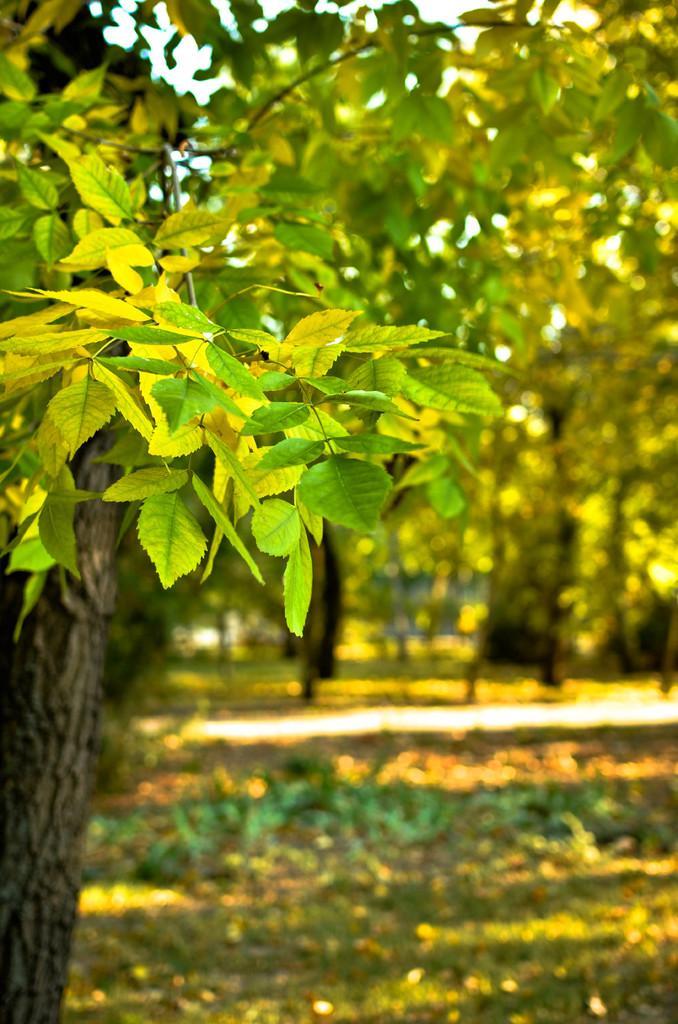In one or two sentences, can you explain what this image depicts? In this image, we can see leaves, stems and tree trunk. In the background, there is a blur view. Here there are few trees, plants, grass and walkway. 